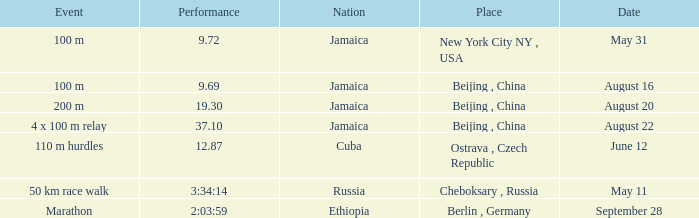What is the area linked to cuba? Ostrava , Czech Republic. 